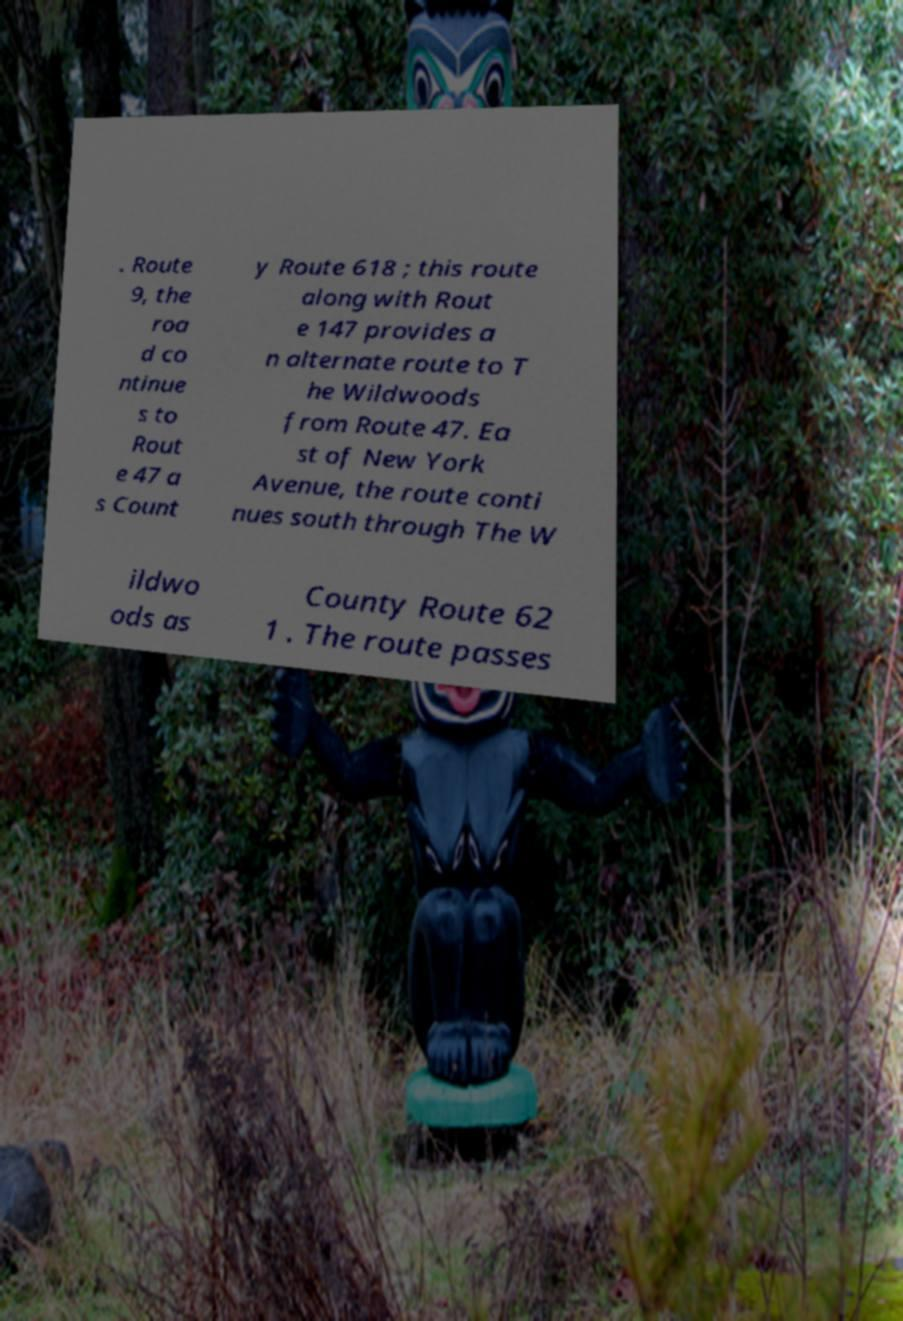For documentation purposes, I need the text within this image transcribed. Could you provide that? . Route 9, the roa d co ntinue s to Rout e 47 a s Count y Route 618 ; this route along with Rout e 147 provides a n alternate route to T he Wildwoods from Route 47. Ea st of New York Avenue, the route conti nues south through The W ildwo ods as County Route 62 1 . The route passes 